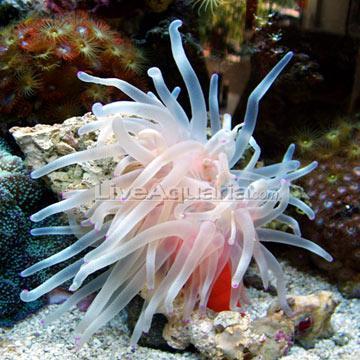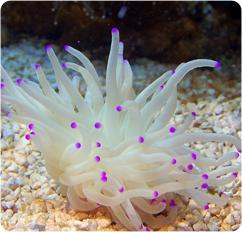The first image is the image on the left, the second image is the image on the right. Considering the images on both sides, is "There are purple dots covering the end of the coral reef’s individual arms." valid? Answer yes or no. Yes. The first image is the image on the left, the second image is the image on the right. Evaluate the accuracy of this statement regarding the images: "An image shows one white anemone with vivid purple dots at the end of its tendrils.". Is it true? Answer yes or no. Yes. 